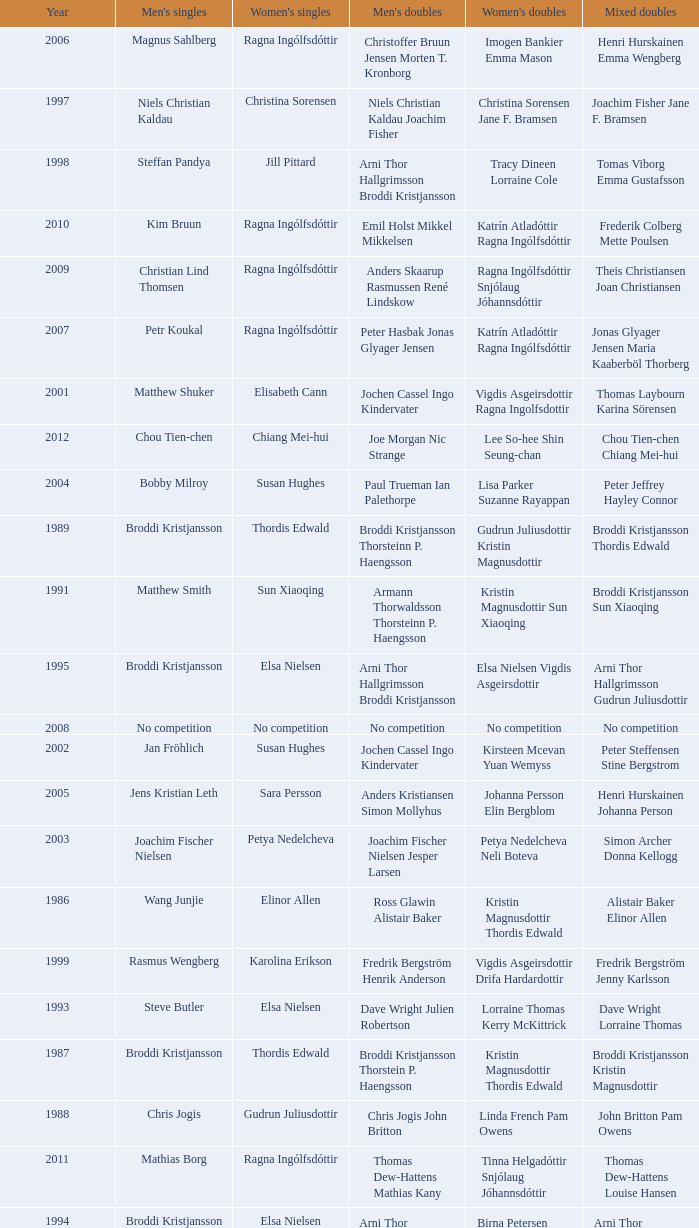In which women's doubles did Wang Junjie play men's singles? Kristin Magnusdottir Thordis Edwald. 